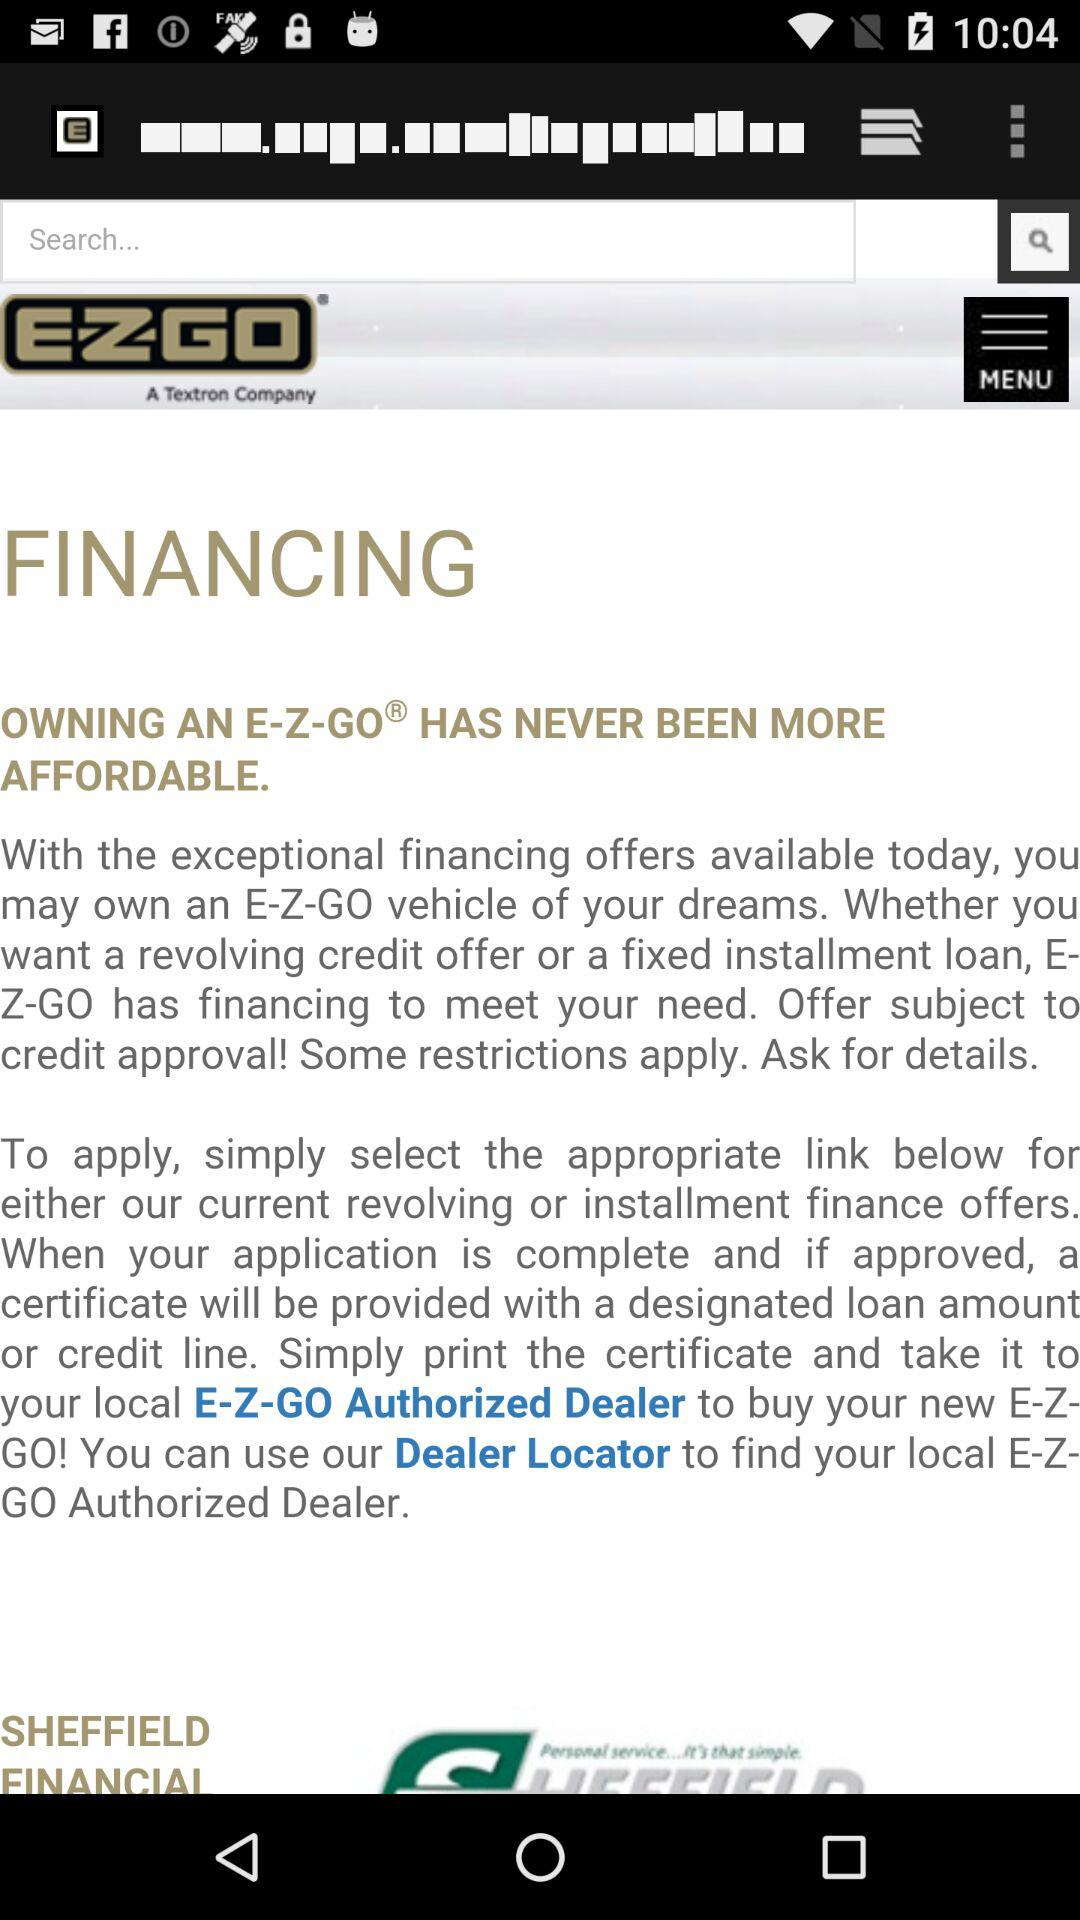What is the company name? The company name is "E-Z-Go". 